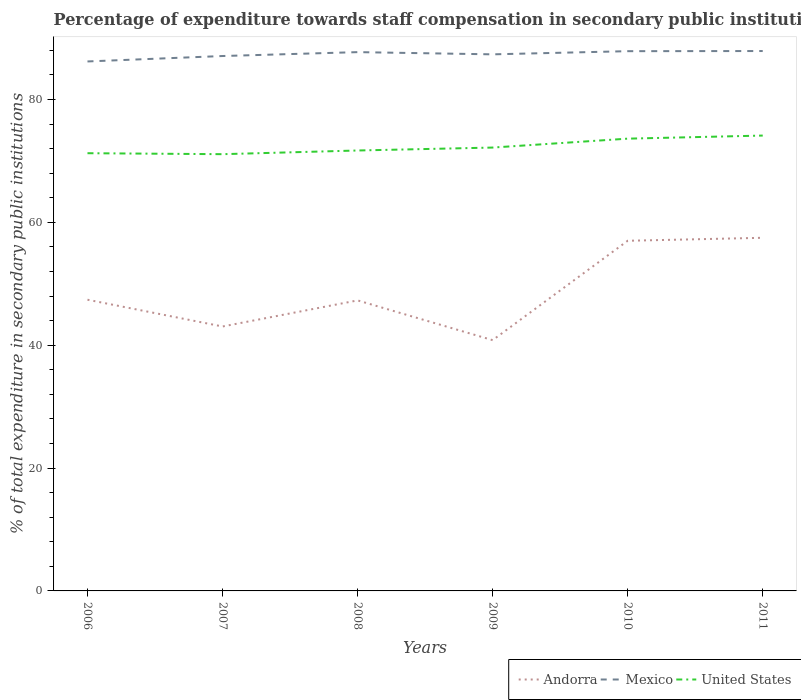How many different coloured lines are there?
Offer a terse response. 3. Across all years, what is the maximum percentage of expenditure towards staff compensation in United States?
Make the answer very short. 71.09. What is the total percentage of expenditure towards staff compensation in Mexico in the graph?
Provide a short and direct response. -0.79. What is the difference between the highest and the second highest percentage of expenditure towards staff compensation in Andorra?
Keep it short and to the point. 16.66. How many years are there in the graph?
Offer a very short reply. 6. What is the difference between two consecutive major ticks on the Y-axis?
Your response must be concise. 20. Are the values on the major ticks of Y-axis written in scientific E-notation?
Keep it short and to the point. No. Does the graph contain any zero values?
Make the answer very short. No. Does the graph contain grids?
Offer a very short reply. No. How are the legend labels stacked?
Give a very brief answer. Horizontal. What is the title of the graph?
Make the answer very short. Percentage of expenditure towards staff compensation in secondary public institutions. Does "Tuvalu" appear as one of the legend labels in the graph?
Make the answer very short. No. What is the label or title of the X-axis?
Your answer should be very brief. Years. What is the label or title of the Y-axis?
Keep it short and to the point. % of total expenditure in secondary public institutions. What is the % of total expenditure in secondary public institutions of Andorra in 2006?
Your answer should be compact. 47.4. What is the % of total expenditure in secondary public institutions of Mexico in 2006?
Ensure brevity in your answer.  86.18. What is the % of total expenditure in secondary public institutions in United States in 2006?
Your answer should be compact. 71.25. What is the % of total expenditure in secondary public institutions of Andorra in 2007?
Your answer should be very brief. 43.04. What is the % of total expenditure in secondary public institutions of Mexico in 2007?
Offer a terse response. 87.07. What is the % of total expenditure in secondary public institutions in United States in 2007?
Make the answer very short. 71.09. What is the % of total expenditure in secondary public institutions in Andorra in 2008?
Your response must be concise. 47.29. What is the % of total expenditure in secondary public institutions of Mexico in 2008?
Give a very brief answer. 87.7. What is the % of total expenditure in secondary public institutions in United States in 2008?
Your answer should be very brief. 71.69. What is the % of total expenditure in secondary public institutions in Andorra in 2009?
Your answer should be compact. 40.82. What is the % of total expenditure in secondary public institutions of Mexico in 2009?
Provide a succinct answer. 87.34. What is the % of total expenditure in secondary public institutions in United States in 2009?
Your answer should be very brief. 72.17. What is the % of total expenditure in secondary public institutions in Andorra in 2010?
Ensure brevity in your answer.  56.99. What is the % of total expenditure in secondary public institutions of Mexico in 2010?
Your response must be concise. 87.85. What is the % of total expenditure in secondary public institutions in United States in 2010?
Ensure brevity in your answer.  73.62. What is the % of total expenditure in secondary public institutions in Andorra in 2011?
Offer a very short reply. 57.48. What is the % of total expenditure in secondary public institutions in Mexico in 2011?
Your answer should be compact. 87.88. What is the % of total expenditure in secondary public institutions of United States in 2011?
Keep it short and to the point. 74.12. Across all years, what is the maximum % of total expenditure in secondary public institutions in Andorra?
Keep it short and to the point. 57.48. Across all years, what is the maximum % of total expenditure in secondary public institutions in Mexico?
Your answer should be very brief. 87.88. Across all years, what is the maximum % of total expenditure in secondary public institutions of United States?
Ensure brevity in your answer.  74.12. Across all years, what is the minimum % of total expenditure in secondary public institutions of Andorra?
Your response must be concise. 40.82. Across all years, what is the minimum % of total expenditure in secondary public institutions in Mexico?
Your answer should be very brief. 86.18. Across all years, what is the minimum % of total expenditure in secondary public institutions in United States?
Provide a succinct answer. 71.09. What is the total % of total expenditure in secondary public institutions of Andorra in the graph?
Provide a short and direct response. 293.02. What is the total % of total expenditure in secondary public institutions in Mexico in the graph?
Your answer should be compact. 524.02. What is the total % of total expenditure in secondary public institutions in United States in the graph?
Provide a succinct answer. 433.92. What is the difference between the % of total expenditure in secondary public institutions of Andorra in 2006 and that in 2007?
Provide a short and direct response. 4.36. What is the difference between the % of total expenditure in secondary public institutions of Mexico in 2006 and that in 2007?
Provide a short and direct response. -0.88. What is the difference between the % of total expenditure in secondary public institutions of United States in 2006 and that in 2007?
Offer a very short reply. 0.16. What is the difference between the % of total expenditure in secondary public institutions in Andorra in 2006 and that in 2008?
Your response must be concise. 0.11. What is the difference between the % of total expenditure in secondary public institutions of Mexico in 2006 and that in 2008?
Provide a succinct answer. -1.52. What is the difference between the % of total expenditure in secondary public institutions in United States in 2006 and that in 2008?
Keep it short and to the point. -0.44. What is the difference between the % of total expenditure in secondary public institutions of Andorra in 2006 and that in 2009?
Provide a short and direct response. 6.58. What is the difference between the % of total expenditure in secondary public institutions in Mexico in 2006 and that in 2009?
Provide a short and direct response. -1.16. What is the difference between the % of total expenditure in secondary public institutions of United States in 2006 and that in 2009?
Provide a succinct answer. -0.92. What is the difference between the % of total expenditure in secondary public institutions in Andorra in 2006 and that in 2010?
Keep it short and to the point. -9.59. What is the difference between the % of total expenditure in secondary public institutions of Mexico in 2006 and that in 2010?
Your answer should be compact. -1.67. What is the difference between the % of total expenditure in secondary public institutions of United States in 2006 and that in 2010?
Keep it short and to the point. -2.37. What is the difference between the % of total expenditure in secondary public institutions in Andorra in 2006 and that in 2011?
Give a very brief answer. -10.08. What is the difference between the % of total expenditure in secondary public institutions of Mexico in 2006 and that in 2011?
Offer a terse response. -1.7. What is the difference between the % of total expenditure in secondary public institutions of United States in 2006 and that in 2011?
Offer a terse response. -2.87. What is the difference between the % of total expenditure in secondary public institutions in Andorra in 2007 and that in 2008?
Offer a terse response. -4.25. What is the difference between the % of total expenditure in secondary public institutions in Mexico in 2007 and that in 2008?
Ensure brevity in your answer.  -0.63. What is the difference between the % of total expenditure in secondary public institutions of United States in 2007 and that in 2008?
Your response must be concise. -0.6. What is the difference between the % of total expenditure in secondary public institutions in Andorra in 2007 and that in 2009?
Your response must be concise. 2.22. What is the difference between the % of total expenditure in secondary public institutions of Mexico in 2007 and that in 2009?
Ensure brevity in your answer.  -0.27. What is the difference between the % of total expenditure in secondary public institutions in United States in 2007 and that in 2009?
Ensure brevity in your answer.  -1.08. What is the difference between the % of total expenditure in secondary public institutions of Andorra in 2007 and that in 2010?
Make the answer very short. -13.95. What is the difference between the % of total expenditure in secondary public institutions of Mexico in 2007 and that in 2010?
Provide a short and direct response. -0.79. What is the difference between the % of total expenditure in secondary public institutions of United States in 2007 and that in 2010?
Provide a succinct answer. -2.53. What is the difference between the % of total expenditure in secondary public institutions in Andorra in 2007 and that in 2011?
Your response must be concise. -14.44. What is the difference between the % of total expenditure in secondary public institutions in Mexico in 2007 and that in 2011?
Make the answer very short. -0.81. What is the difference between the % of total expenditure in secondary public institutions of United States in 2007 and that in 2011?
Offer a very short reply. -3.03. What is the difference between the % of total expenditure in secondary public institutions of Andorra in 2008 and that in 2009?
Your answer should be very brief. 6.47. What is the difference between the % of total expenditure in secondary public institutions in Mexico in 2008 and that in 2009?
Provide a succinct answer. 0.36. What is the difference between the % of total expenditure in secondary public institutions of United States in 2008 and that in 2009?
Offer a terse response. -0.48. What is the difference between the % of total expenditure in secondary public institutions of Andorra in 2008 and that in 2010?
Your answer should be compact. -9.71. What is the difference between the % of total expenditure in secondary public institutions in Mexico in 2008 and that in 2010?
Ensure brevity in your answer.  -0.15. What is the difference between the % of total expenditure in secondary public institutions in United States in 2008 and that in 2010?
Give a very brief answer. -1.93. What is the difference between the % of total expenditure in secondary public institutions of Andorra in 2008 and that in 2011?
Offer a terse response. -10.19. What is the difference between the % of total expenditure in secondary public institutions of Mexico in 2008 and that in 2011?
Your answer should be compact. -0.18. What is the difference between the % of total expenditure in secondary public institutions of United States in 2008 and that in 2011?
Your answer should be compact. -2.43. What is the difference between the % of total expenditure in secondary public institutions in Andorra in 2009 and that in 2010?
Your response must be concise. -16.18. What is the difference between the % of total expenditure in secondary public institutions of Mexico in 2009 and that in 2010?
Keep it short and to the point. -0.52. What is the difference between the % of total expenditure in secondary public institutions of United States in 2009 and that in 2010?
Give a very brief answer. -1.45. What is the difference between the % of total expenditure in secondary public institutions in Andorra in 2009 and that in 2011?
Ensure brevity in your answer.  -16.66. What is the difference between the % of total expenditure in secondary public institutions of Mexico in 2009 and that in 2011?
Ensure brevity in your answer.  -0.54. What is the difference between the % of total expenditure in secondary public institutions of United States in 2009 and that in 2011?
Provide a succinct answer. -1.95. What is the difference between the % of total expenditure in secondary public institutions of Andorra in 2010 and that in 2011?
Your response must be concise. -0.49. What is the difference between the % of total expenditure in secondary public institutions in Mexico in 2010 and that in 2011?
Provide a succinct answer. -0.02. What is the difference between the % of total expenditure in secondary public institutions in United States in 2010 and that in 2011?
Offer a terse response. -0.5. What is the difference between the % of total expenditure in secondary public institutions in Andorra in 2006 and the % of total expenditure in secondary public institutions in Mexico in 2007?
Give a very brief answer. -39.67. What is the difference between the % of total expenditure in secondary public institutions of Andorra in 2006 and the % of total expenditure in secondary public institutions of United States in 2007?
Your answer should be very brief. -23.69. What is the difference between the % of total expenditure in secondary public institutions in Mexico in 2006 and the % of total expenditure in secondary public institutions in United States in 2007?
Your response must be concise. 15.09. What is the difference between the % of total expenditure in secondary public institutions in Andorra in 2006 and the % of total expenditure in secondary public institutions in Mexico in 2008?
Give a very brief answer. -40.3. What is the difference between the % of total expenditure in secondary public institutions of Andorra in 2006 and the % of total expenditure in secondary public institutions of United States in 2008?
Give a very brief answer. -24.29. What is the difference between the % of total expenditure in secondary public institutions in Mexico in 2006 and the % of total expenditure in secondary public institutions in United States in 2008?
Your answer should be compact. 14.49. What is the difference between the % of total expenditure in secondary public institutions of Andorra in 2006 and the % of total expenditure in secondary public institutions of Mexico in 2009?
Ensure brevity in your answer.  -39.94. What is the difference between the % of total expenditure in secondary public institutions of Andorra in 2006 and the % of total expenditure in secondary public institutions of United States in 2009?
Ensure brevity in your answer.  -24.77. What is the difference between the % of total expenditure in secondary public institutions in Mexico in 2006 and the % of total expenditure in secondary public institutions in United States in 2009?
Ensure brevity in your answer.  14.02. What is the difference between the % of total expenditure in secondary public institutions of Andorra in 2006 and the % of total expenditure in secondary public institutions of Mexico in 2010?
Your answer should be very brief. -40.46. What is the difference between the % of total expenditure in secondary public institutions of Andorra in 2006 and the % of total expenditure in secondary public institutions of United States in 2010?
Offer a very short reply. -26.22. What is the difference between the % of total expenditure in secondary public institutions in Mexico in 2006 and the % of total expenditure in secondary public institutions in United States in 2010?
Your response must be concise. 12.57. What is the difference between the % of total expenditure in secondary public institutions in Andorra in 2006 and the % of total expenditure in secondary public institutions in Mexico in 2011?
Offer a terse response. -40.48. What is the difference between the % of total expenditure in secondary public institutions of Andorra in 2006 and the % of total expenditure in secondary public institutions of United States in 2011?
Your answer should be compact. -26.72. What is the difference between the % of total expenditure in secondary public institutions of Mexico in 2006 and the % of total expenditure in secondary public institutions of United States in 2011?
Ensure brevity in your answer.  12.06. What is the difference between the % of total expenditure in secondary public institutions in Andorra in 2007 and the % of total expenditure in secondary public institutions in Mexico in 2008?
Give a very brief answer. -44.66. What is the difference between the % of total expenditure in secondary public institutions in Andorra in 2007 and the % of total expenditure in secondary public institutions in United States in 2008?
Give a very brief answer. -28.65. What is the difference between the % of total expenditure in secondary public institutions in Mexico in 2007 and the % of total expenditure in secondary public institutions in United States in 2008?
Offer a terse response. 15.38. What is the difference between the % of total expenditure in secondary public institutions of Andorra in 2007 and the % of total expenditure in secondary public institutions of Mexico in 2009?
Offer a terse response. -44.3. What is the difference between the % of total expenditure in secondary public institutions in Andorra in 2007 and the % of total expenditure in secondary public institutions in United States in 2009?
Give a very brief answer. -29.12. What is the difference between the % of total expenditure in secondary public institutions in Mexico in 2007 and the % of total expenditure in secondary public institutions in United States in 2009?
Offer a very short reply. 14.9. What is the difference between the % of total expenditure in secondary public institutions in Andorra in 2007 and the % of total expenditure in secondary public institutions in Mexico in 2010?
Offer a very short reply. -44.81. What is the difference between the % of total expenditure in secondary public institutions of Andorra in 2007 and the % of total expenditure in secondary public institutions of United States in 2010?
Keep it short and to the point. -30.57. What is the difference between the % of total expenditure in secondary public institutions in Mexico in 2007 and the % of total expenditure in secondary public institutions in United States in 2010?
Offer a terse response. 13.45. What is the difference between the % of total expenditure in secondary public institutions in Andorra in 2007 and the % of total expenditure in secondary public institutions in Mexico in 2011?
Your response must be concise. -44.84. What is the difference between the % of total expenditure in secondary public institutions in Andorra in 2007 and the % of total expenditure in secondary public institutions in United States in 2011?
Keep it short and to the point. -31.08. What is the difference between the % of total expenditure in secondary public institutions in Mexico in 2007 and the % of total expenditure in secondary public institutions in United States in 2011?
Your response must be concise. 12.95. What is the difference between the % of total expenditure in secondary public institutions of Andorra in 2008 and the % of total expenditure in secondary public institutions of Mexico in 2009?
Give a very brief answer. -40.05. What is the difference between the % of total expenditure in secondary public institutions in Andorra in 2008 and the % of total expenditure in secondary public institutions in United States in 2009?
Keep it short and to the point. -24.88. What is the difference between the % of total expenditure in secondary public institutions in Mexico in 2008 and the % of total expenditure in secondary public institutions in United States in 2009?
Offer a terse response. 15.53. What is the difference between the % of total expenditure in secondary public institutions in Andorra in 2008 and the % of total expenditure in secondary public institutions in Mexico in 2010?
Your answer should be very brief. -40.57. What is the difference between the % of total expenditure in secondary public institutions in Andorra in 2008 and the % of total expenditure in secondary public institutions in United States in 2010?
Your response must be concise. -26.33. What is the difference between the % of total expenditure in secondary public institutions of Mexico in 2008 and the % of total expenditure in secondary public institutions of United States in 2010?
Your answer should be compact. 14.08. What is the difference between the % of total expenditure in secondary public institutions of Andorra in 2008 and the % of total expenditure in secondary public institutions of Mexico in 2011?
Your answer should be compact. -40.59. What is the difference between the % of total expenditure in secondary public institutions in Andorra in 2008 and the % of total expenditure in secondary public institutions in United States in 2011?
Give a very brief answer. -26.83. What is the difference between the % of total expenditure in secondary public institutions in Mexico in 2008 and the % of total expenditure in secondary public institutions in United States in 2011?
Your answer should be very brief. 13.58. What is the difference between the % of total expenditure in secondary public institutions in Andorra in 2009 and the % of total expenditure in secondary public institutions in Mexico in 2010?
Provide a succinct answer. -47.04. What is the difference between the % of total expenditure in secondary public institutions of Andorra in 2009 and the % of total expenditure in secondary public institutions of United States in 2010?
Ensure brevity in your answer.  -32.8. What is the difference between the % of total expenditure in secondary public institutions of Mexico in 2009 and the % of total expenditure in secondary public institutions of United States in 2010?
Give a very brief answer. 13.72. What is the difference between the % of total expenditure in secondary public institutions of Andorra in 2009 and the % of total expenditure in secondary public institutions of Mexico in 2011?
Give a very brief answer. -47.06. What is the difference between the % of total expenditure in secondary public institutions of Andorra in 2009 and the % of total expenditure in secondary public institutions of United States in 2011?
Your response must be concise. -33.3. What is the difference between the % of total expenditure in secondary public institutions in Mexico in 2009 and the % of total expenditure in secondary public institutions in United States in 2011?
Offer a very short reply. 13.22. What is the difference between the % of total expenditure in secondary public institutions of Andorra in 2010 and the % of total expenditure in secondary public institutions of Mexico in 2011?
Give a very brief answer. -30.88. What is the difference between the % of total expenditure in secondary public institutions of Andorra in 2010 and the % of total expenditure in secondary public institutions of United States in 2011?
Your answer should be compact. -17.12. What is the difference between the % of total expenditure in secondary public institutions in Mexico in 2010 and the % of total expenditure in secondary public institutions in United States in 2011?
Offer a very short reply. 13.74. What is the average % of total expenditure in secondary public institutions in Andorra per year?
Keep it short and to the point. 48.84. What is the average % of total expenditure in secondary public institutions of Mexico per year?
Provide a succinct answer. 87.34. What is the average % of total expenditure in secondary public institutions of United States per year?
Your answer should be compact. 72.32. In the year 2006, what is the difference between the % of total expenditure in secondary public institutions of Andorra and % of total expenditure in secondary public institutions of Mexico?
Give a very brief answer. -38.78. In the year 2006, what is the difference between the % of total expenditure in secondary public institutions in Andorra and % of total expenditure in secondary public institutions in United States?
Offer a terse response. -23.85. In the year 2006, what is the difference between the % of total expenditure in secondary public institutions of Mexico and % of total expenditure in secondary public institutions of United States?
Ensure brevity in your answer.  14.93. In the year 2007, what is the difference between the % of total expenditure in secondary public institutions in Andorra and % of total expenditure in secondary public institutions in Mexico?
Keep it short and to the point. -44.02. In the year 2007, what is the difference between the % of total expenditure in secondary public institutions of Andorra and % of total expenditure in secondary public institutions of United States?
Keep it short and to the point. -28.05. In the year 2007, what is the difference between the % of total expenditure in secondary public institutions in Mexico and % of total expenditure in secondary public institutions in United States?
Provide a short and direct response. 15.98. In the year 2008, what is the difference between the % of total expenditure in secondary public institutions in Andorra and % of total expenditure in secondary public institutions in Mexico?
Make the answer very short. -40.41. In the year 2008, what is the difference between the % of total expenditure in secondary public institutions in Andorra and % of total expenditure in secondary public institutions in United States?
Give a very brief answer. -24.4. In the year 2008, what is the difference between the % of total expenditure in secondary public institutions in Mexico and % of total expenditure in secondary public institutions in United States?
Your answer should be very brief. 16.01. In the year 2009, what is the difference between the % of total expenditure in secondary public institutions in Andorra and % of total expenditure in secondary public institutions in Mexico?
Your answer should be very brief. -46.52. In the year 2009, what is the difference between the % of total expenditure in secondary public institutions in Andorra and % of total expenditure in secondary public institutions in United States?
Give a very brief answer. -31.35. In the year 2009, what is the difference between the % of total expenditure in secondary public institutions of Mexico and % of total expenditure in secondary public institutions of United States?
Provide a short and direct response. 15.17. In the year 2010, what is the difference between the % of total expenditure in secondary public institutions in Andorra and % of total expenditure in secondary public institutions in Mexico?
Your response must be concise. -30.86. In the year 2010, what is the difference between the % of total expenditure in secondary public institutions in Andorra and % of total expenditure in secondary public institutions in United States?
Your answer should be very brief. -16.62. In the year 2010, what is the difference between the % of total expenditure in secondary public institutions in Mexico and % of total expenditure in secondary public institutions in United States?
Provide a succinct answer. 14.24. In the year 2011, what is the difference between the % of total expenditure in secondary public institutions of Andorra and % of total expenditure in secondary public institutions of Mexico?
Your answer should be compact. -30.4. In the year 2011, what is the difference between the % of total expenditure in secondary public institutions of Andorra and % of total expenditure in secondary public institutions of United States?
Provide a succinct answer. -16.64. In the year 2011, what is the difference between the % of total expenditure in secondary public institutions of Mexico and % of total expenditure in secondary public institutions of United States?
Provide a succinct answer. 13.76. What is the ratio of the % of total expenditure in secondary public institutions in Andorra in 2006 to that in 2007?
Offer a terse response. 1.1. What is the ratio of the % of total expenditure in secondary public institutions in Mexico in 2006 to that in 2007?
Offer a terse response. 0.99. What is the ratio of the % of total expenditure in secondary public institutions in Andorra in 2006 to that in 2008?
Offer a very short reply. 1. What is the ratio of the % of total expenditure in secondary public institutions in Mexico in 2006 to that in 2008?
Your answer should be compact. 0.98. What is the ratio of the % of total expenditure in secondary public institutions of United States in 2006 to that in 2008?
Your answer should be very brief. 0.99. What is the ratio of the % of total expenditure in secondary public institutions of Andorra in 2006 to that in 2009?
Your response must be concise. 1.16. What is the ratio of the % of total expenditure in secondary public institutions in United States in 2006 to that in 2009?
Your response must be concise. 0.99. What is the ratio of the % of total expenditure in secondary public institutions in Andorra in 2006 to that in 2010?
Provide a succinct answer. 0.83. What is the ratio of the % of total expenditure in secondary public institutions of United States in 2006 to that in 2010?
Make the answer very short. 0.97. What is the ratio of the % of total expenditure in secondary public institutions of Andorra in 2006 to that in 2011?
Offer a terse response. 0.82. What is the ratio of the % of total expenditure in secondary public institutions in Mexico in 2006 to that in 2011?
Provide a succinct answer. 0.98. What is the ratio of the % of total expenditure in secondary public institutions of United States in 2006 to that in 2011?
Make the answer very short. 0.96. What is the ratio of the % of total expenditure in secondary public institutions in Andorra in 2007 to that in 2008?
Your answer should be very brief. 0.91. What is the ratio of the % of total expenditure in secondary public institutions of Mexico in 2007 to that in 2008?
Make the answer very short. 0.99. What is the ratio of the % of total expenditure in secondary public institutions of Andorra in 2007 to that in 2009?
Offer a very short reply. 1.05. What is the ratio of the % of total expenditure in secondary public institutions in Mexico in 2007 to that in 2009?
Keep it short and to the point. 1. What is the ratio of the % of total expenditure in secondary public institutions of United States in 2007 to that in 2009?
Keep it short and to the point. 0.99. What is the ratio of the % of total expenditure in secondary public institutions in Andorra in 2007 to that in 2010?
Ensure brevity in your answer.  0.76. What is the ratio of the % of total expenditure in secondary public institutions of United States in 2007 to that in 2010?
Your response must be concise. 0.97. What is the ratio of the % of total expenditure in secondary public institutions in Andorra in 2007 to that in 2011?
Your answer should be compact. 0.75. What is the ratio of the % of total expenditure in secondary public institutions in United States in 2007 to that in 2011?
Provide a succinct answer. 0.96. What is the ratio of the % of total expenditure in secondary public institutions in Andorra in 2008 to that in 2009?
Your response must be concise. 1.16. What is the ratio of the % of total expenditure in secondary public institutions of Mexico in 2008 to that in 2009?
Give a very brief answer. 1. What is the ratio of the % of total expenditure in secondary public institutions of United States in 2008 to that in 2009?
Your response must be concise. 0.99. What is the ratio of the % of total expenditure in secondary public institutions in Andorra in 2008 to that in 2010?
Make the answer very short. 0.83. What is the ratio of the % of total expenditure in secondary public institutions of United States in 2008 to that in 2010?
Offer a terse response. 0.97. What is the ratio of the % of total expenditure in secondary public institutions in Andorra in 2008 to that in 2011?
Your answer should be compact. 0.82. What is the ratio of the % of total expenditure in secondary public institutions of Mexico in 2008 to that in 2011?
Your response must be concise. 1. What is the ratio of the % of total expenditure in secondary public institutions of United States in 2008 to that in 2011?
Offer a very short reply. 0.97. What is the ratio of the % of total expenditure in secondary public institutions of Andorra in 2009 to that in 2010?
Offer a very short reply. 0.72. What is the ratio of the % of total expenditure in secondary public institutions of United States in 2009 to that in 2010?
Keep it short and to the point. 0.98. What is the ratio of the % of total expenditure in secondary public institutions in Andorra in 2009 to that in 2011?
Make the answer very short. 0.71. What is the ratio of the % of total expenditure in secondary public institutions of Mexico in 2009 to that in 2011?
Make the answer very short. 0.99. What is the ratio of the % of total expenditure in secondary public institutions of United States in 2009 to that in 2011?
Provide a short and direct response. 0.97. What is the ratio of the % of total expenditure in secondary public institutions of Andorra in 2010 to that in 2011?
Offer a very short reply. 0.99. What is the ratio of the % of total expenditure in secondary public institutions in Mexico in 2010 to that in 2011?
Your answer should be compact. 1. What is the ratio of the % of total expenditure in secondary public institutions of United States in 2010 to that in 2011?
Make the answer very short. 0.99. What is the difference between the highest and the second highest % of total expenditure in secondary public institutions of Andorra?
Give a very brief answer. 0.49. What is the difference between the highest and the second highest % of total expenditure in secondary public institutions of Mexico?
Ensure brevity in your answer.  0.02. What is the difference between the highest and the second highest % of total expenditure in secondary public institutions in United States?
Ensure brevity in your answer.  0.5. What is the difference between the highest and the lowest % of total expenditure in secondary public institutions in Andorra?
Provide a short and direct response. 16.66. What is the difference between the highest and the lowest % of total expenditure in secondary public institutions of Mexico?
Make the answer very short. 1.7. What is the difference between the highest and the lowest % of total expenditure in secondary public institutions in United States?
Your response must be concise. 3.03. 